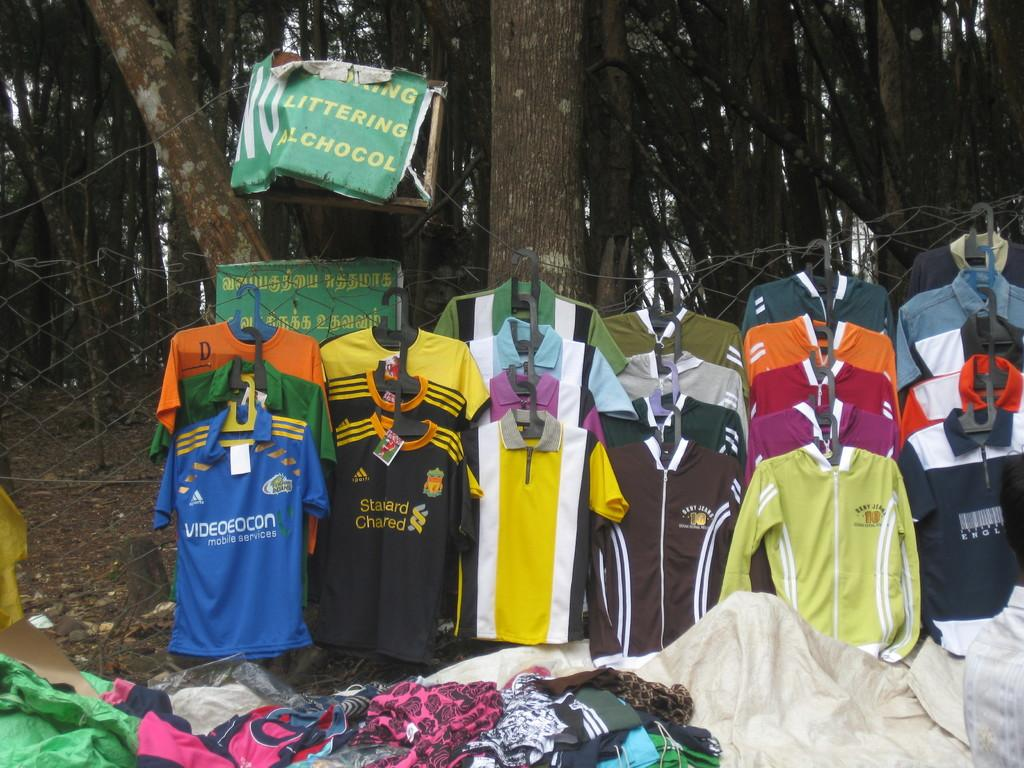<image>
Share a concise interpretation of the image provided. Colorful jerseys are hung out for a display under a tree and a sign saying No Alcohol. 